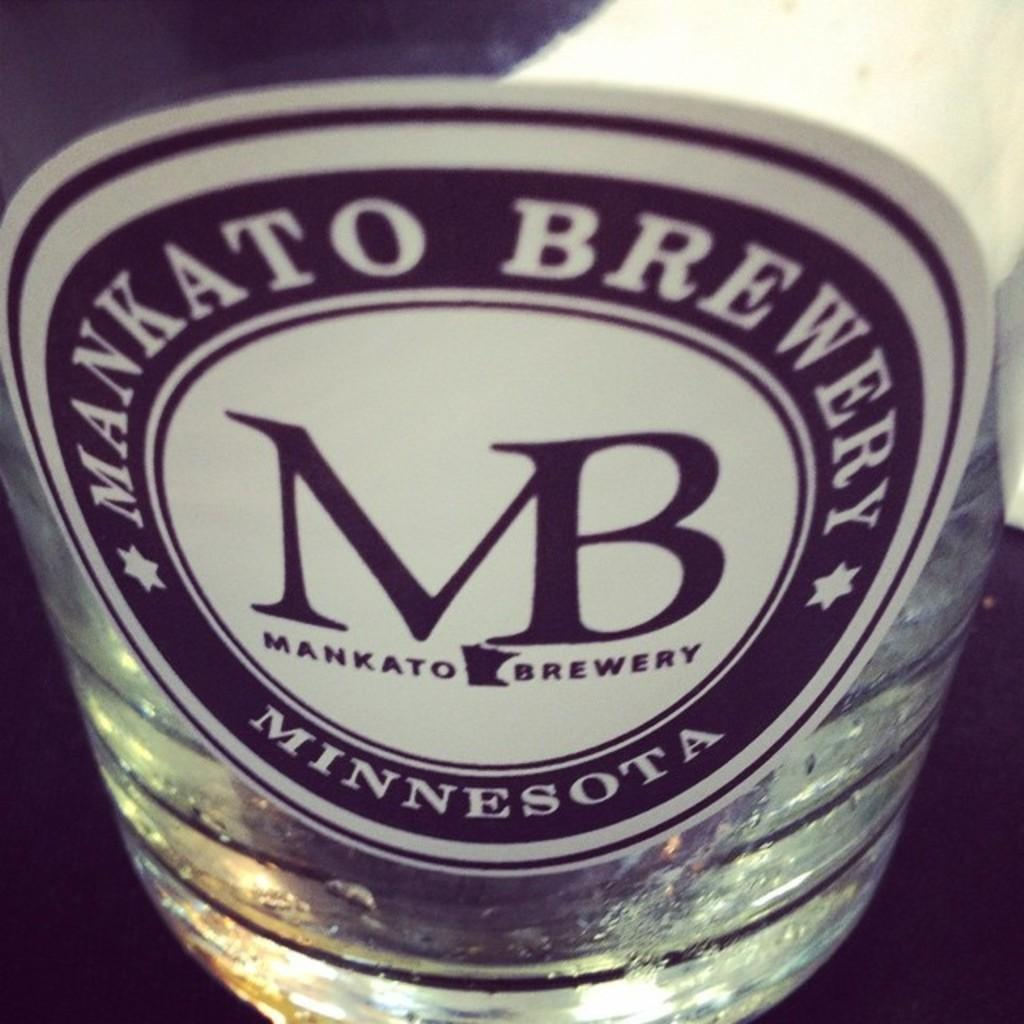Provide a one-sentence caption for the provided image. The beer bottle is from Mankato Brewery Minnesota. 